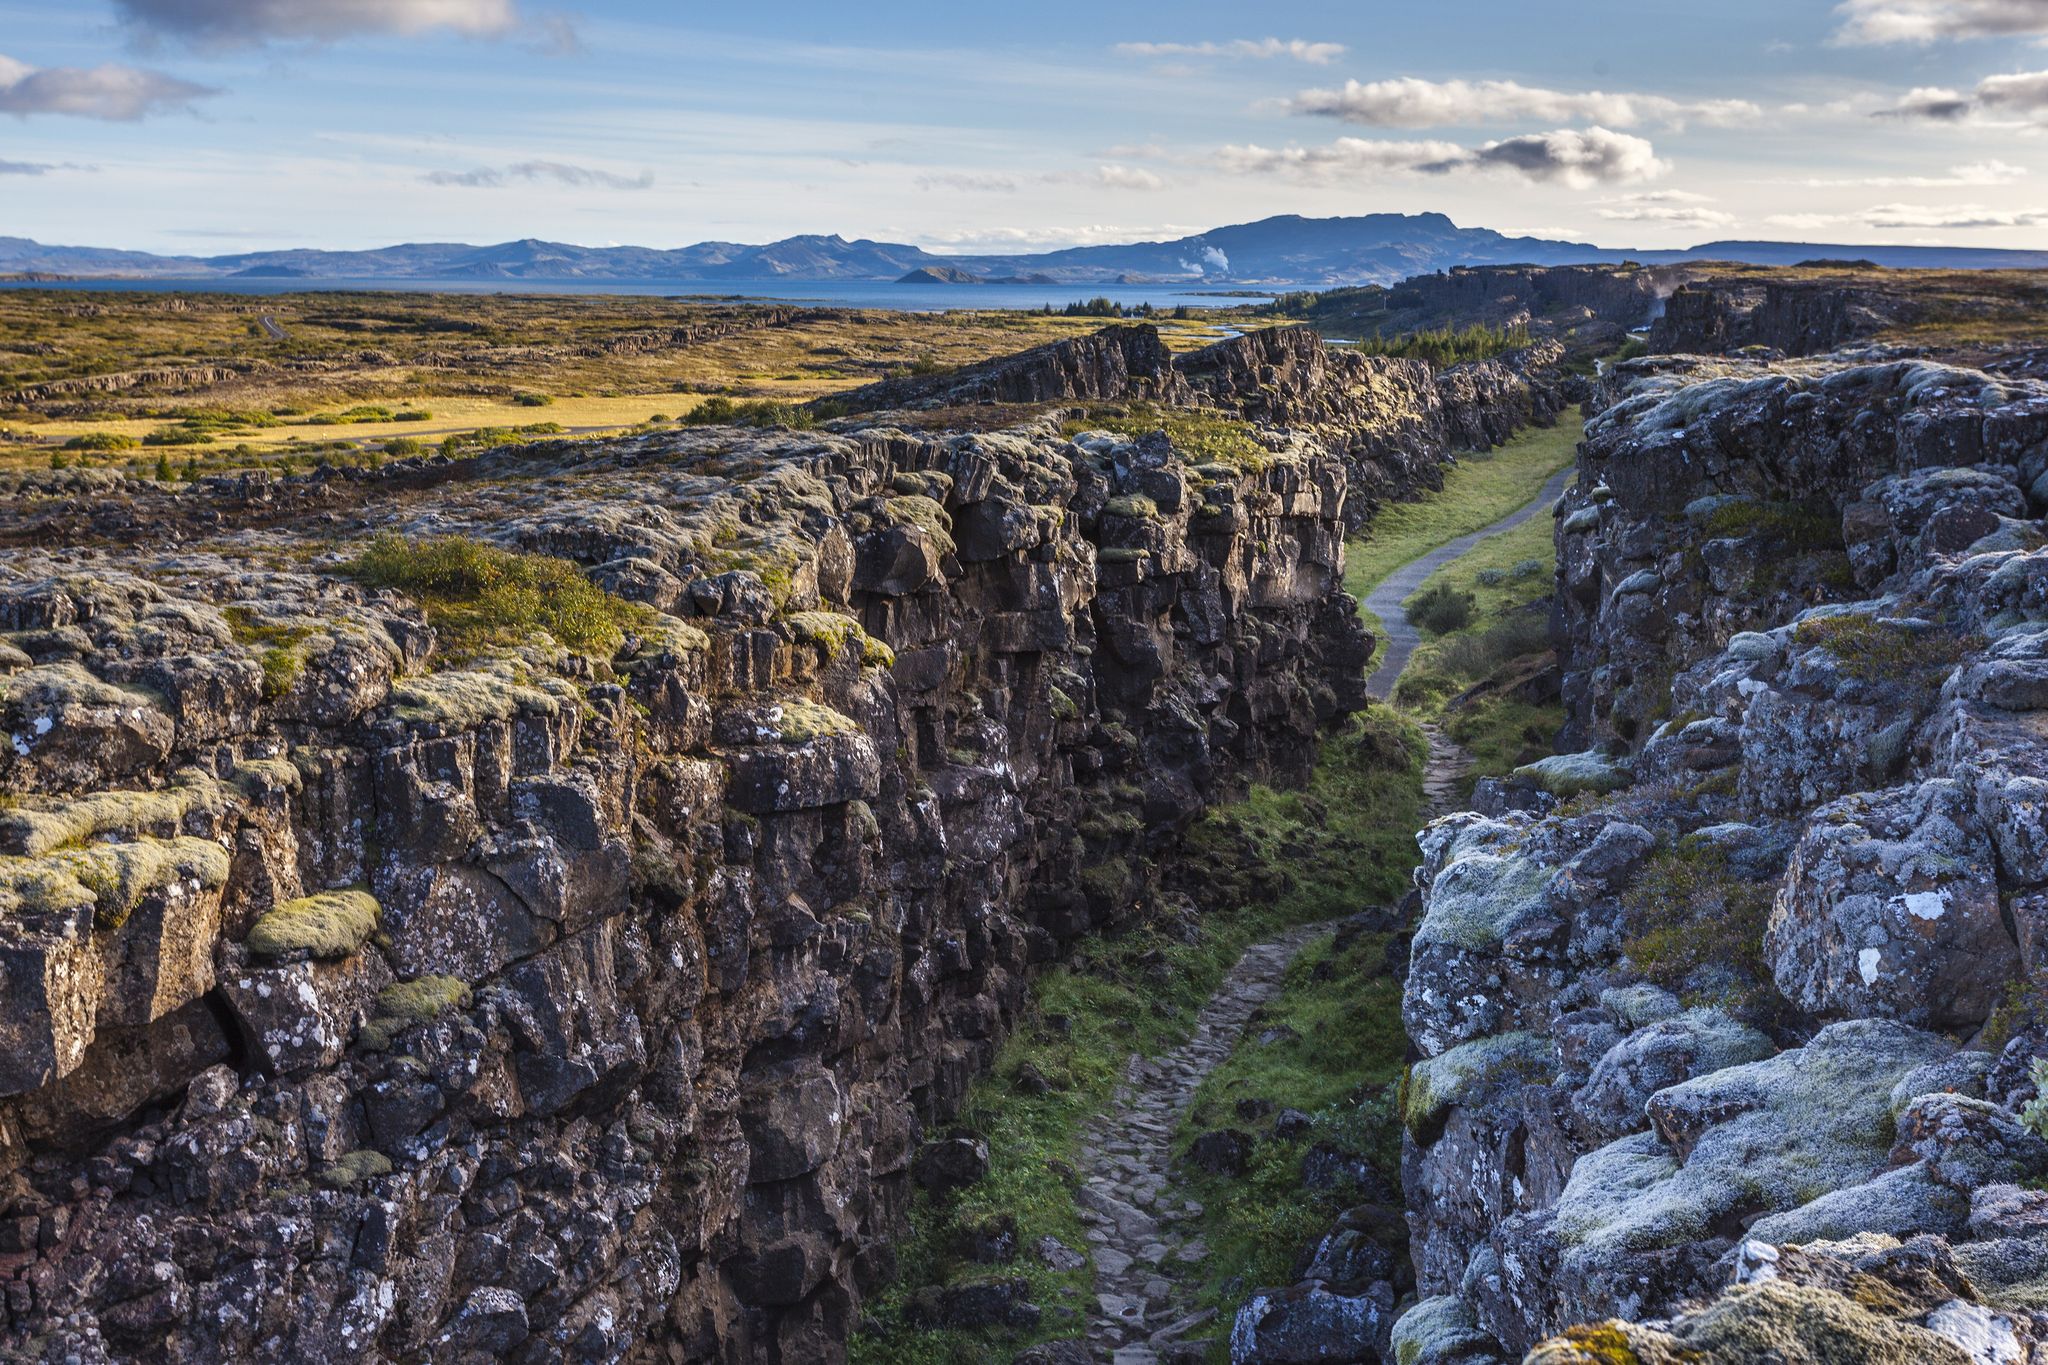What unique geological features are present in this photo? This photo prominently features the stunning Almannagjá fault line at Þingvellir National Park, a unique geological landmark where the Eurasian and North American tectonic plates meet and slowly drift apart. The rugged cliffs forming the walls of the gorge are part of this rift zone. The path within the gorge follows the fault line, providing a unique opportunity to walk between two continents. The scene is enriched by the verdant vegetation clinging to the rocky surfaces, exemplifying the dynamic interplay between geological processes and natural beauty. 